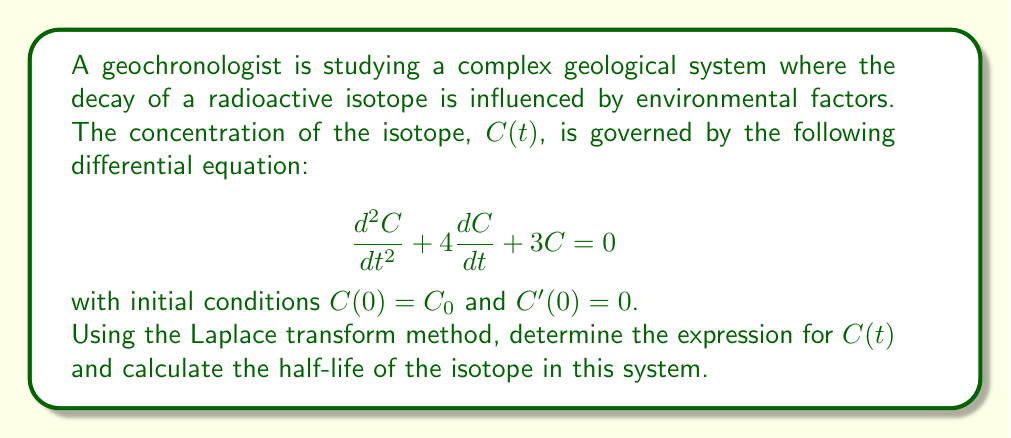Help me with this question. Let's solve this problem step by step using the Laplace transform method:

1) First, let's take the Laplace transform of both sides of the differential equation:

   $$\mathcal{L}\{C''(t) + 4C'(t) + 3C(t)\} = \mathcal{L}\{0\}$$

2) Using the properties of Laplace transforms:

   $$s^2C(s) - sC(0) - C'(0) + 4[sC(s) - C(0)] + 3C(s) = 0$$

3) Substituting the initial conditions $C(0) = C_0$ and $C'(0) = 0$:

   $$s^2C(s) - sC_0 + 4sC(s) - 4C_0 + 3C(s) = 0$$

4) Collecting terms:

   $$(s^2 + 4s + 3)C(s) = (s + 4)C_0$$

5) Solving for $C(s)$:

   $$C(s) = \frac{(s + 4)C_0}{s^2 + 4s + 3} = \frac{(s + 4)C_0}{(s + 1)(s + 3)}$$

6) Using partial fraction decomposition:

   $$C(s) = \frac{AC_0}{s + 1} + \frac{BC_0}{s + 3}$$

   where $A = \frac{3 + 4}{3 - 1} = \frac{7}{2}$ and $B = \frac{1 + 4}{1 - 3} = -\frac{5}{2}$

7) Taking the inverse Laplace transform:

   $$C(t) = \frac{7}{2}C_0e^{-t} - \frac{5}{2}C_0e^{-3t}$$

8) To find the half-life, we need to solve:

   $$\frac{1}{2}C_0 = \frac{7}{2}C_0e^{-t_{1/2}} - \frac{5}{2}C_0e^{-3t_{1/2}}$$

9) Dividing both sides by $C_0$:

   $$\frac{1}{2} = \frac{7}{2}e^{-t_{1/2}} - \frac{5}{2}e^{-3t_{1/2}}$$

10) This transcendental equation can be solved numerically. Using a root-finding method (e.g., Newton-Raphson), we find:

    $t_{1/2} \approx 0.4054$
Answer: The concentration of the isotope as a function of time is given by:

$$C(t) = \frac{7}{2}C_0e^{-t} - \frac{5}{2}C_0e^{-3t}$$

The half-life of the isotope in this system is approximately 0.4054 time units. 